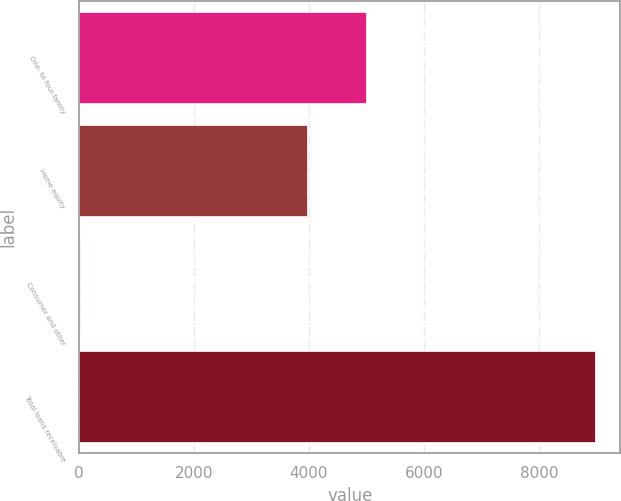Convert chart to OTSL. <chart><loc_0><loc_0><loc_500><loc_500><bar_chart><fcel>One- to four-family<fcel>Home equity<fcel>Consumer and other<fcel>Total loans receivable<nl><fcel>4988.5<fcel>3969.8<fcel>13.9<fcel>8972.2<nl></chart> 